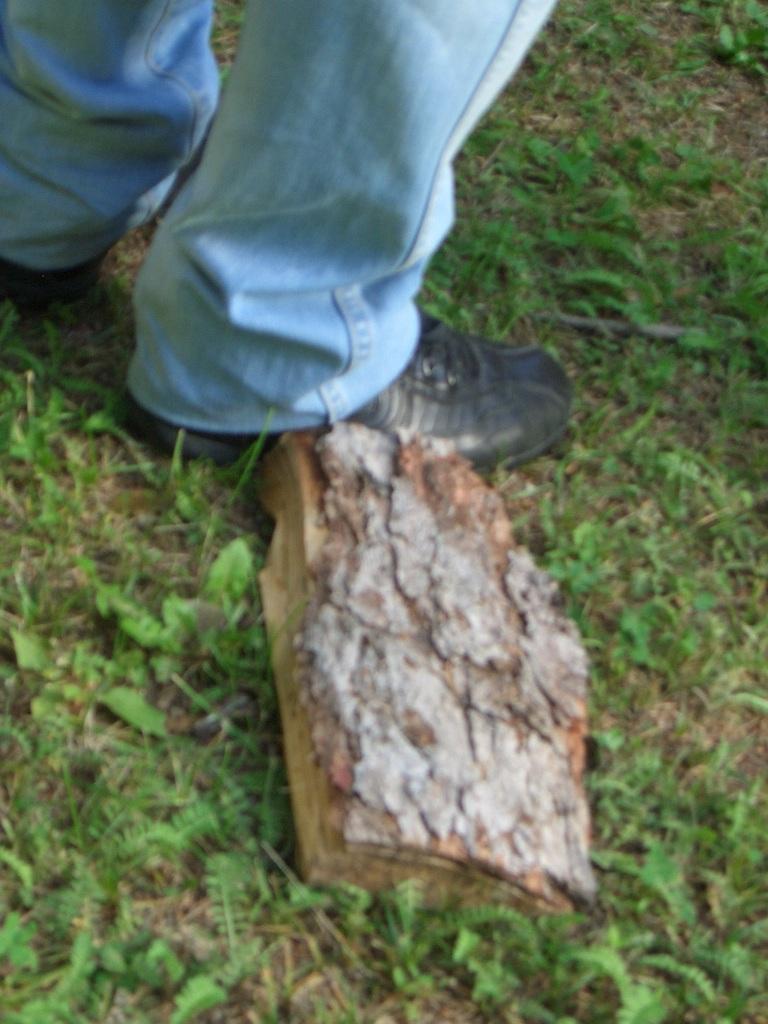How would you summarize this image in a sentence or two? There is a wooden piece on the grassland in the foreground area of the image, there are legs of a person at the top side. 